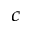Convert formula to latex. <formula><loc_0><loc_0><loc_500><loc_500>_ { c }</formula> 